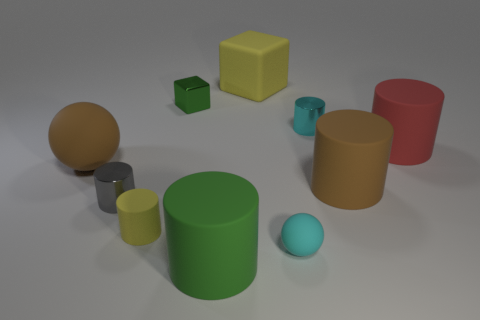How many large cubes are the same color as the big ball?
Your answer should be very brief. 0. What number of small things are either green metallic things or yellow cubes?
Provide a succinct answer. 1. Is there another object of the same shape as the red rubber thing?
Keep it short and to the point. Yes. Do the red matte object and the green metal object have the same shape?
Keep it short and to the point. No. There is a large thing behind the metal cylinder on the right side of the big green matte object; what color is it?
Your response must be concise. Yellow. There is a ball that is the same size as the yellow cube; what color is it?
Make the answer very short. Brown. What number of shiny things are either blocks or yellow objects?
Your response must be concise. 1. What number of small things are right of the yellow object that is behind the big rubber sphere?
Provide a short and direct response. 2. What size is the object that is the same color as the small cube?
Ensure brevity in your answer.  Large. What number of objects are small blocks or rubber objects that are in front of the tiny cyan cylinder?
Give a very brief answer. 7. 